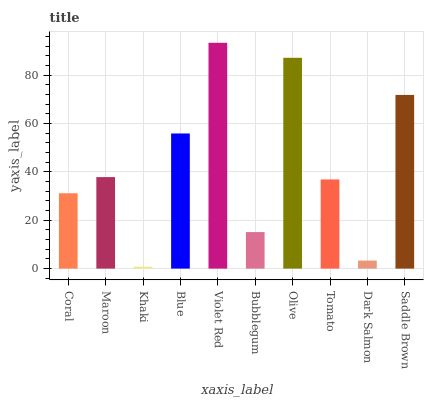Is Khaki the minimum?
Answer yes or no. Yes. Is Violet Red the maximum?
Answer yes or no. Yes. Is Maroon the minimum?
Answer yes or no. No. Is Maroon the maximum?
Answer yes or no. No. Is Maroon greater than Coral?
Answer yes or no. Yes. Is Coral less than Maroon?
Answer yes or no. Yes. Is Coral greater than Maroon?
Answer yes or no. No. Is Maroon less than Coral?
Answer yes or no. No. Is Maroon the high median?
Answer yes or no. Yes. Is Tomato the low median?
Answer yes or no. Yes. Is Khaki the high median?
Answer yes or no. No. Is Coral the low median?
Answer yes or no. No. 